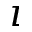Convert formula to latex. <formula><loc_0><loc_0><loc_500><loc_500>\imath</formula> 